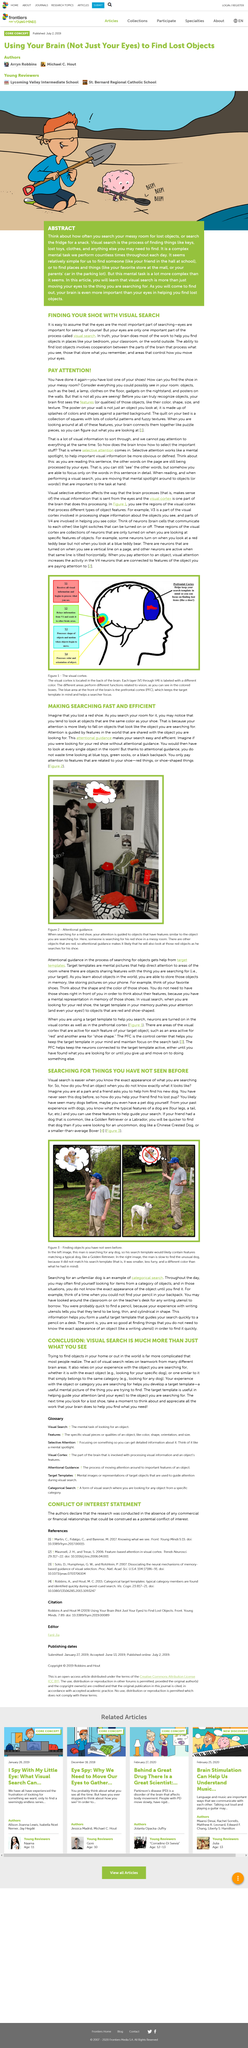Specify some key components in this picture. The man is wearing a blue cap. The visual cortex is located in the back of the brain. The visual cortex contains approximately 4 layers. In Figure 2, the man is likely to look at 5 objects as he searches for the shoe. Attention directed by mental pictures, known as target templates. 